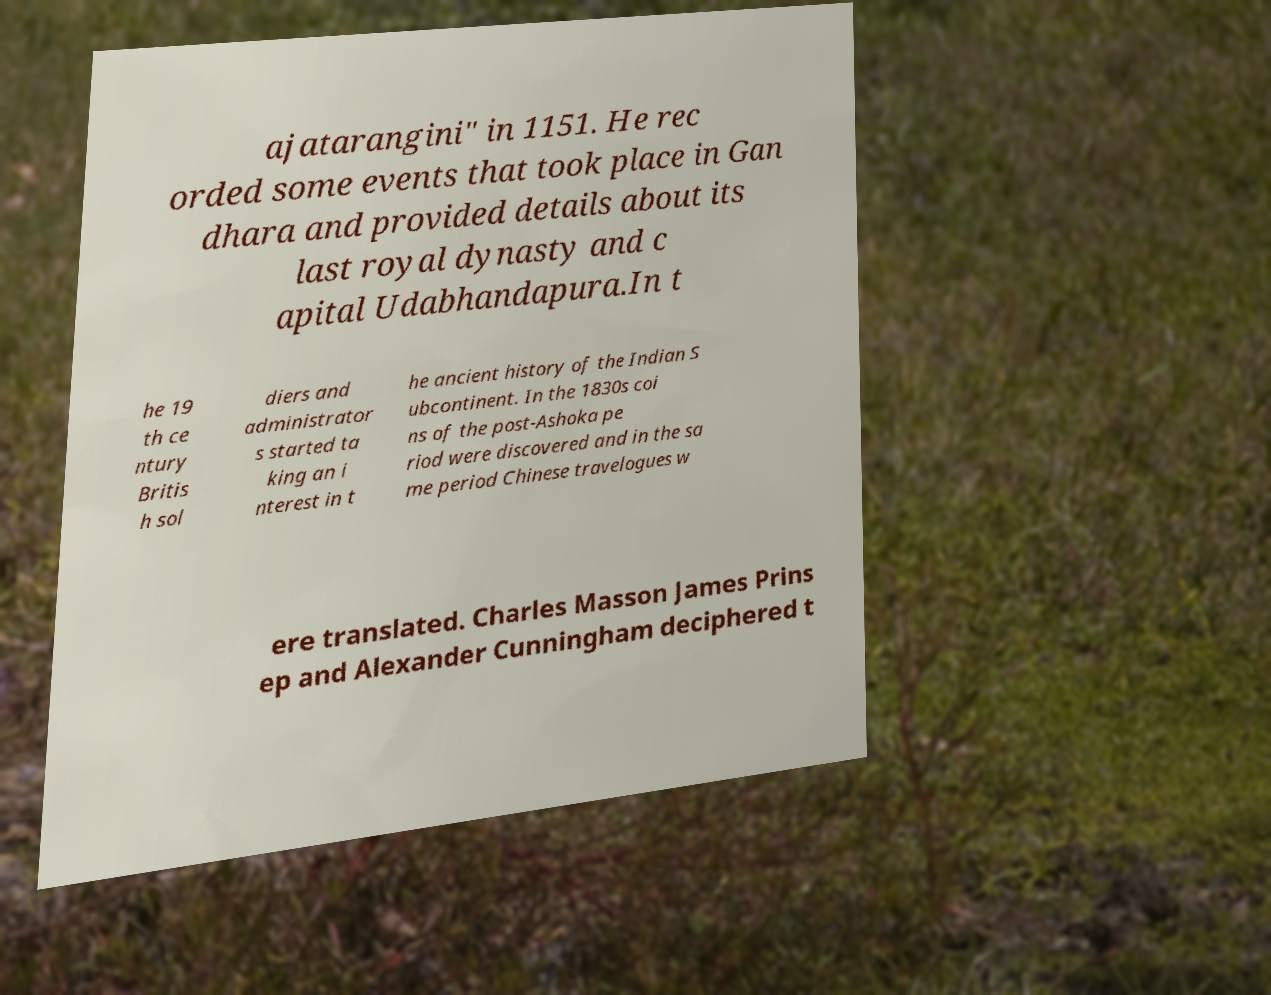Can you accurately transcribe the text from the provided image for me? ajatarangini" in 1151. He rec orded some events that took place in Gan dhara and provided details about its last royal dynasty and c apital Udabhandapura.In t he 19 th ce ntury Britis h sol diers and administrator s started ta king an i nterest in t he ancient history of the Indian S ubcontinent. In the 1830s coi ns of the post-Ashoka pe riod were discovered and in the sa me period Chinese travelogues w ere translated. Charles Masson James Prins ep and Alexander Cunningham deciphered t 